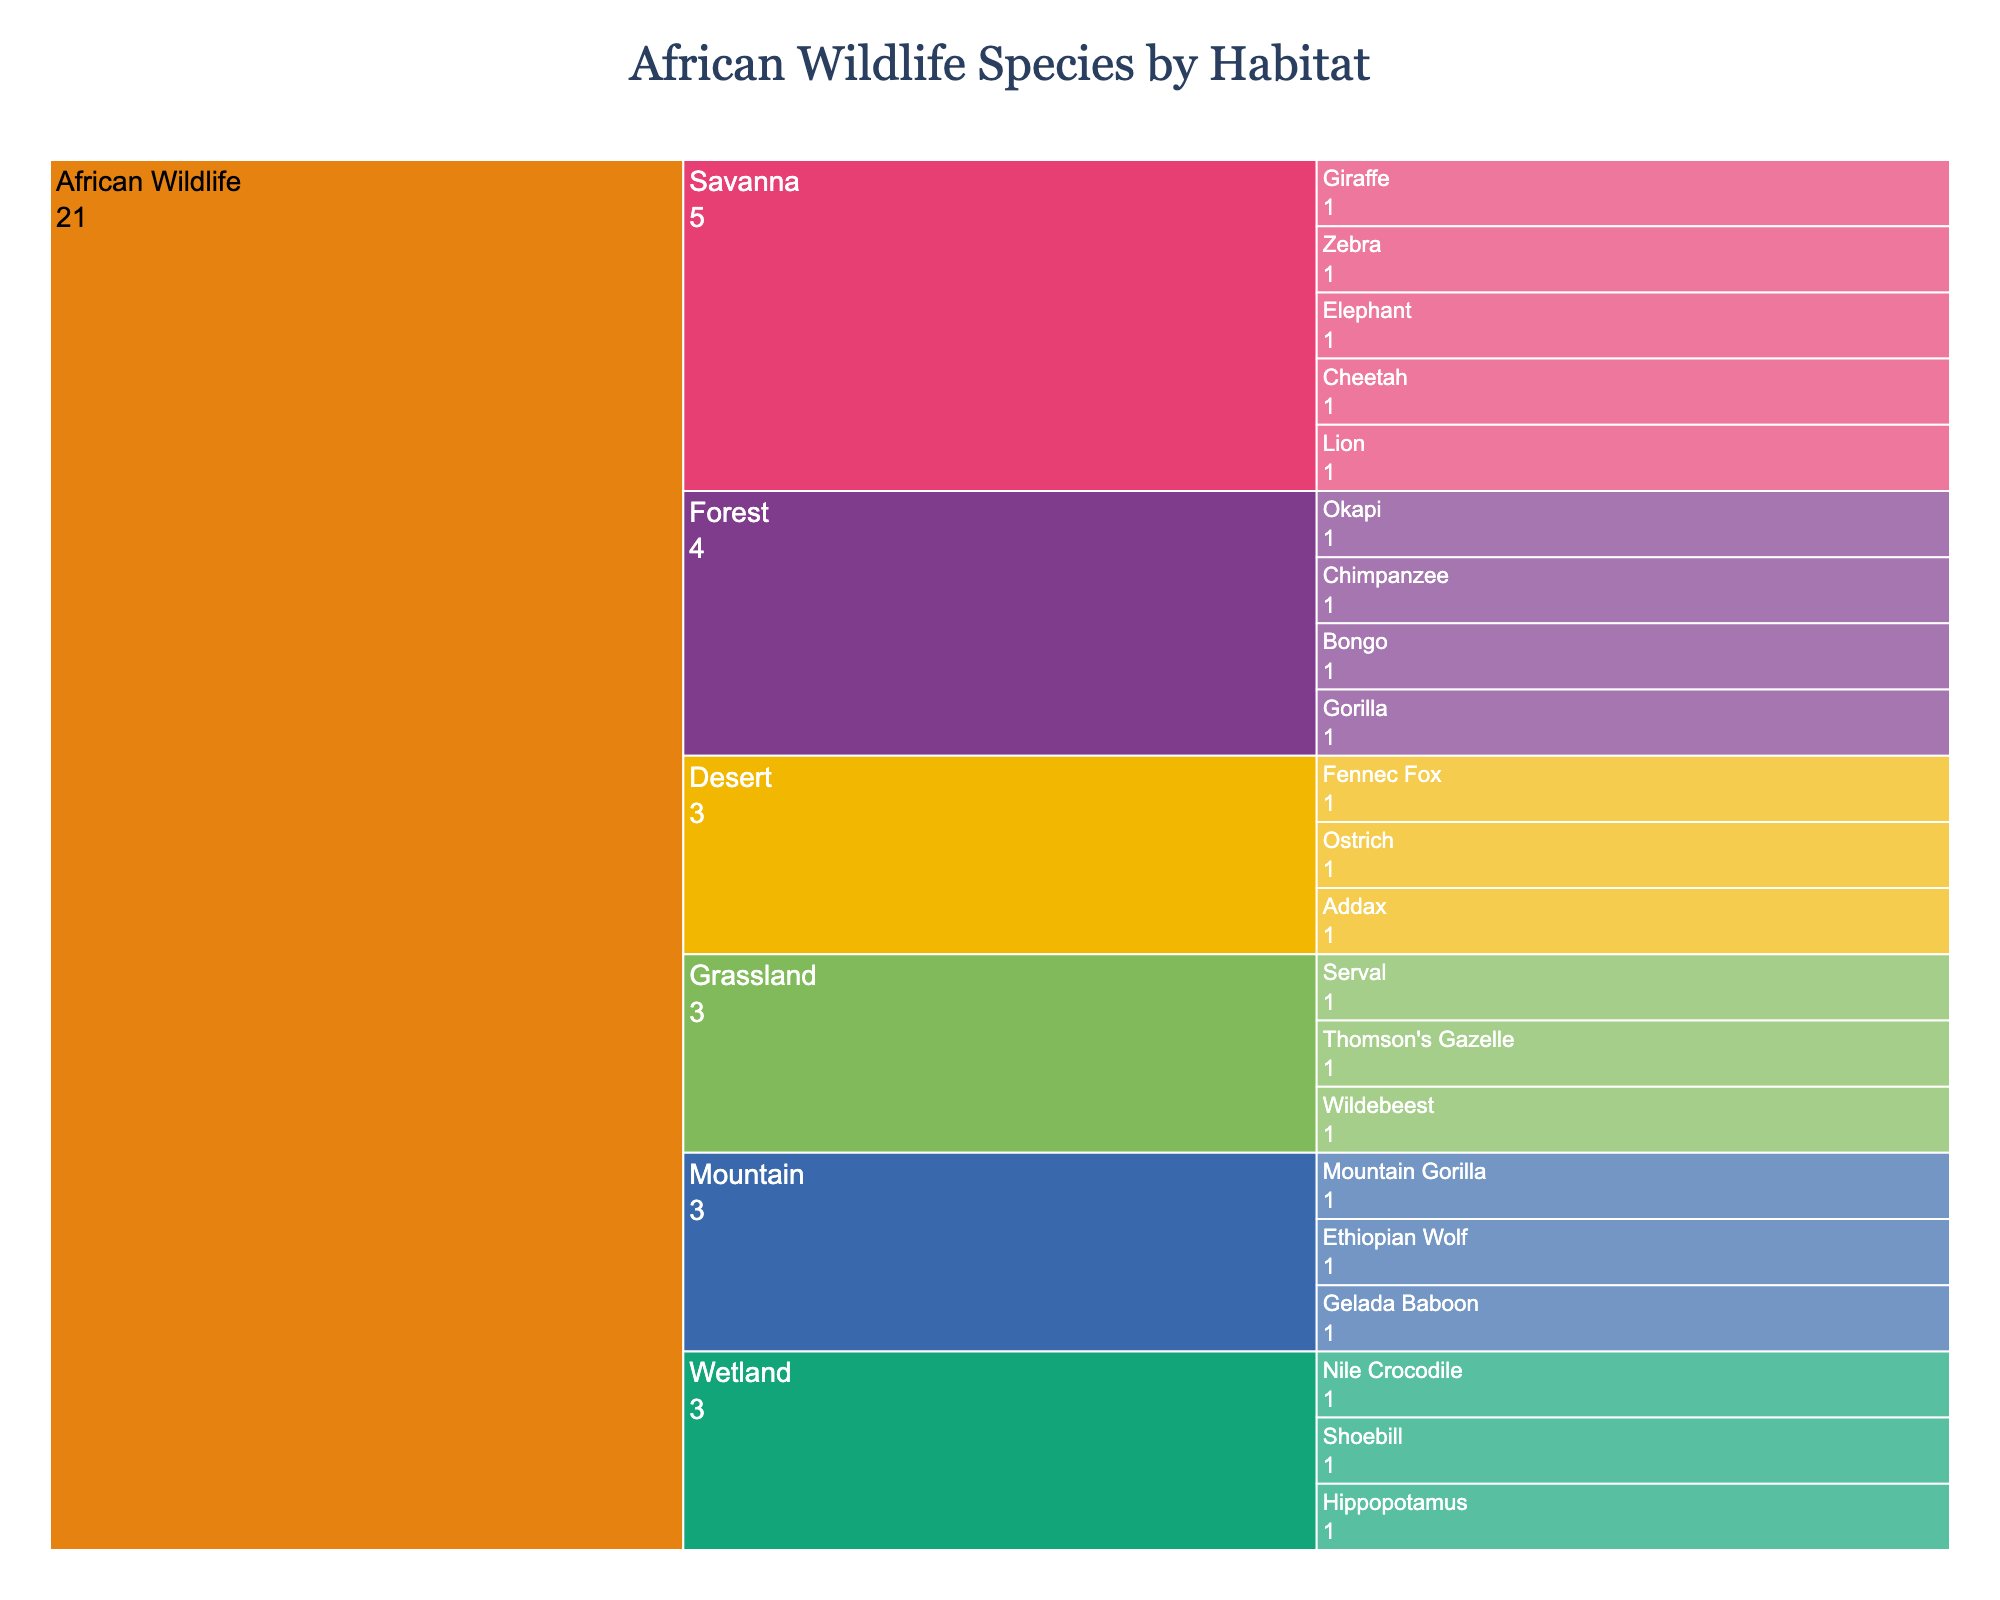What is the title of the icicle chart? The title is located at the top of the chart and usually gives a summary of the visualized data.
Answer: African Wildlife Species by Habitat Which habitat has the highest number of species? By looking at the number of branches under each habitat category, you can see which habitat has the most entries.
Answer: Savanna How many species are found in the Forest habitat? Count the number of species listed under the Forest habitat.
Answer: 4 Which habitat contains only three species? Count the species under each habitat category and identify the one with three species.
Answer: Desert Which species are displayed under the Wetland habitat? Look for the "Wetland" node and list the species branching from it.
Answer: Hippopotamus, Nile Crocodile, Shoebill How many more species are there in the Savanna habitat compared to the Desert habitat? Count the species in both the Savanna and Desert habitats and find the difference. There are 5 species in Savanna and 3 in Desert.
Answer: 2 What is the total number of species across all habitats? Add up the total number of species from all habitats. Savanna (5), Forest (4), Wetland (3), Desert (3), Grassland (3), Mountain (3). 5+4+3+3+3+3 = 21
Answer: 21 Which habitats share Mountain Gorilla as a species? Look at the species listed under each habitat and find where Mountain Gorilla is categorized.
Answer: Forest, Mountain Which habitat has the fewest species, and how many? Compare the number of species under each habitat category and identify the one with the lowest count. Multiple habitats have the same lowest count.
Answer: Wetland, Desert, Grassland, Mountain (3 species each) What percentage of the total species are found in the Grassland habitat? Determine the total number of species (21), count the species in Grassland (3), and calculate the percentage: (3/21)*100 = 14.29%.
Answer: 14.29% 